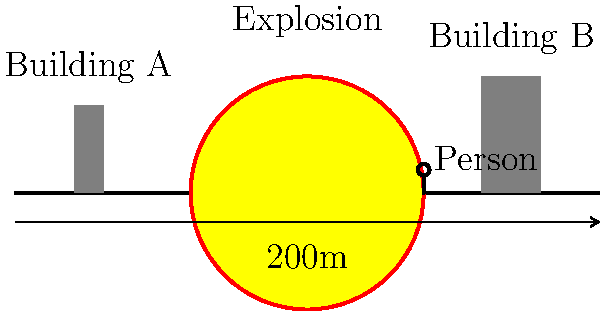Based on the diagram showing an explosion and surrounding structures, estimate the blast radius that would likely cause significant damage to both buildings. Assume the person shown is of average height (1.7m) for scale reference. To estimate the blast radius, we'll follow these steps:

1. Determine the scale of the image:
   - The scale bar shows 200m across the entire width of the image.
   - The image is 10 units wide (-5 to 5).
   - So, 1 unit = 20m (200m / 10 units)

2. Estimate the distance of each building from the explosion center:
   - Building A: ~3.75 units from center
   - Building B: ~3.5 units from center

3. Convert these distances to meters:
   - Building A: 3.75 * 20m = 75m
   - Building B: 3.5 * 20m = 70m

4. Consider the size of the explosion:
   - The explosion circle has a radius of 2 units
   - In meters: 2 * 20m = 40m

5. Estimate the blast radius:
   - To affect both buildings, the blast radius must be at least 75m
   - However, significant damage typically occurs closer to the explosion
   - A reasonable estimate would be between the explosion size and the distance to the nearest building
   - Let's estimate 60m as the blast radius for significant damage

This estimate takes into account the scale of the diagram, the positions of the buildings, and allows for a realistic blast radius that would likely cause significant damage to both structures.
Answer: 60 meters 